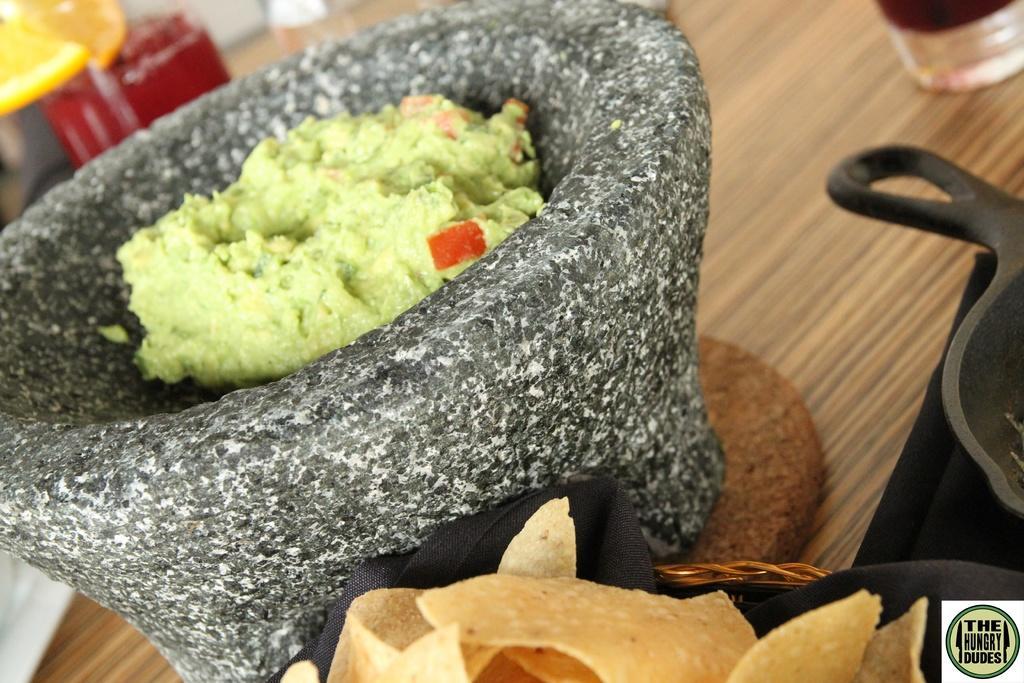Please provide a concise description of this image. In this image we can see a wooden surface. On that there is a mat. On the mat there is a stone object with green color paste. Also we can see chips in a black cloth. And there is a pan and some other objects. 